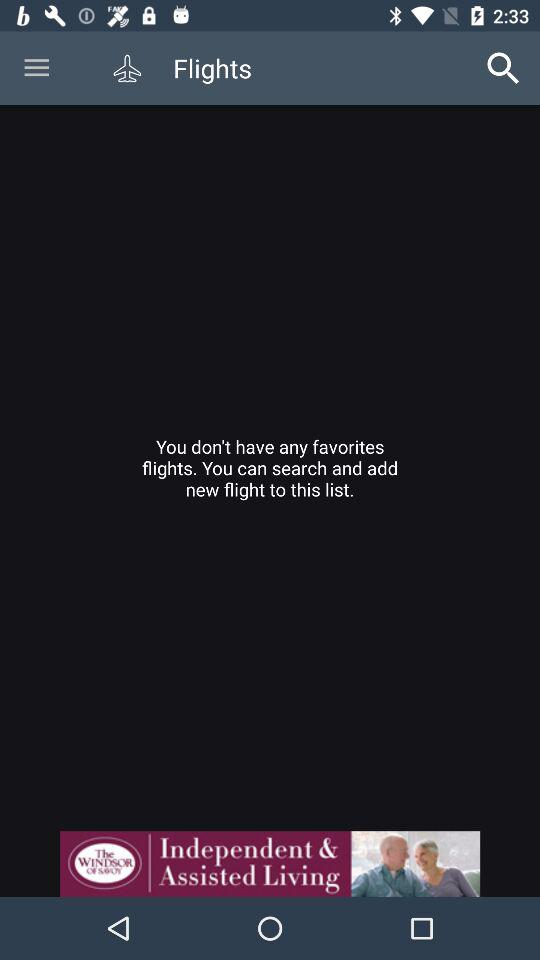Which flights are on my list that I consider to be my favorites? On your list, you don't have any flights. 